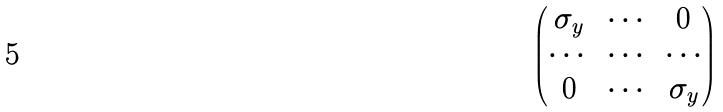<formula> <loc_0><loc_0><loc_500><loc_500>\begin{pmatrix} \sigma _ { y } & \cdots & 0 \\ \cdots & \cdots & \cdots \\ 0 & \cdots & \sigma _ { y } \end{pmatrix}</formula> 